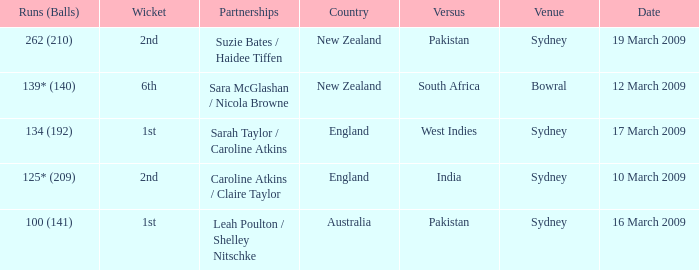How many times has india been the opposing country? 1.0. 